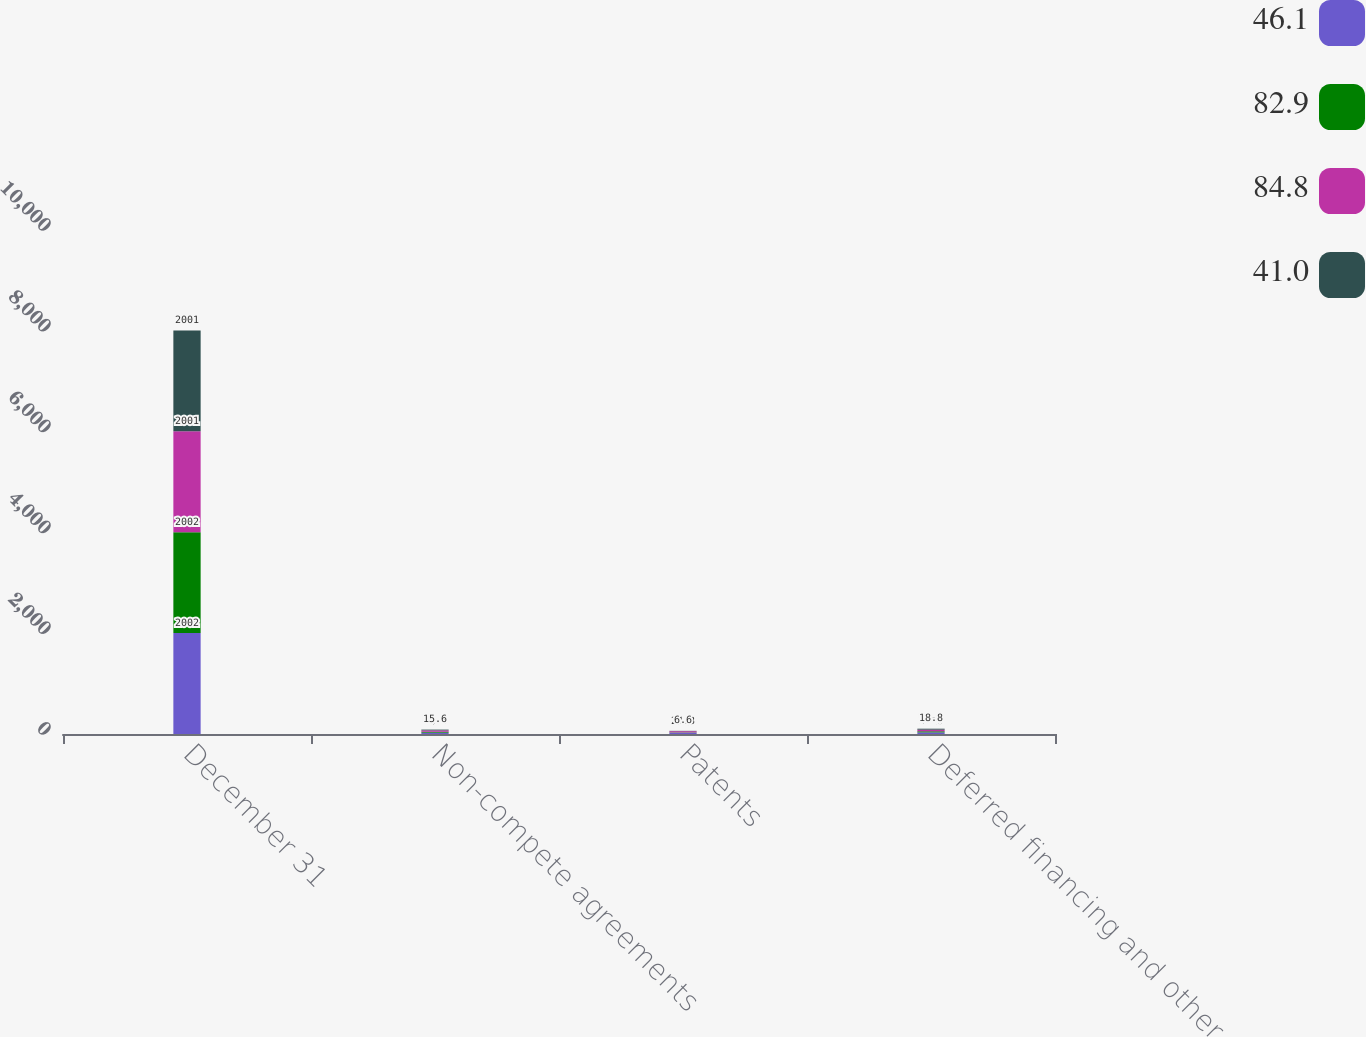Convert chart to OTSL. <chart><loc_0><loc_0><loc_500><loc_500><stacked_bar_chart><ecel><fcel>December 31<fcel>Non-compete agreements<fcel>Patents<fcel>Deferred financing and other<nl><fcel>46.1<fcel>2002<fcel>26.2<fcel>24.7<fcel>32<nl><fcel>82.9<fcel>2002<fcel>17.6<fcel>6.9<fcel>21.6<nl><fcel>84.8<fcel>2001<fcel>27.7<fcel>24.3<fcel>32.8<nl><fcel>41<fcel>2001<fcel>15.6<fcel>6.6<fcel>18.8<nl></chart> 